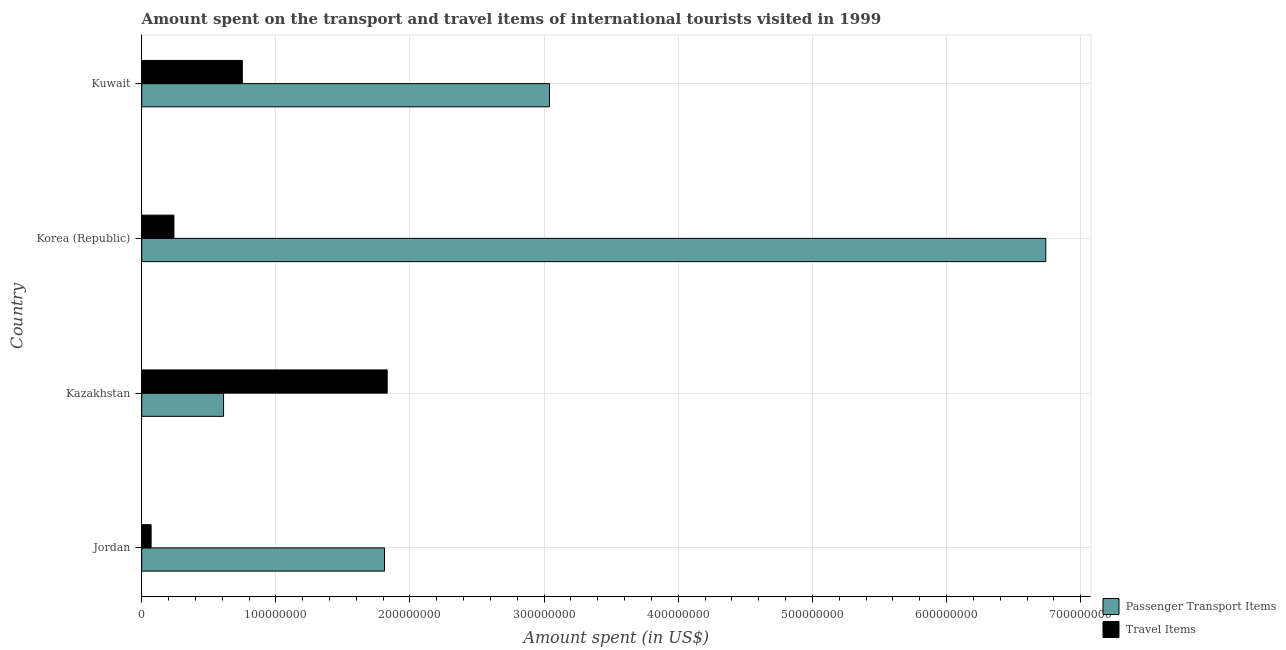Are the number of bars on each tick of the Y-axis equal?
Offer a very short reply. Yes. How many bars are there on the 2nd tick from the bottom?
Offer a terse response. 2. In how many cases, is the number of bars for a given country not equal to the number of legend labels?
Your answer should be very brief. 0. What is the amount spent on passenger transport items in Kazakhstan?
Ensure brevity in your answer.  6.10e+07. Across all countries, what is the maximum amount spent in travel items?
Give a very brief answer. 1.83e+08. Across all countries, what is the minimum amount spent on passenger transport items?
Keep it short and to the point. 6.10e+07. In which country was the amount spent on passenger transport items maximum?
Keep it short and to the point. Korea (Republic). In which country was the amount spent on passenger transport items minimum?
Your answer should be compact. Kazakhstan. What is the total amount spent in travel items in the graph?
Your answer should be compact. 2.89e+08. What is the difference between the amount spent on passenger transport items in Korea (Republic) and that in Kuwait?
Provide a short and direct response. 3.70e+08. What is the difference between the amount spent in travel items in Kuwait and the amount spent on passenger transport items in Jordan?
Ensure brevity in your answer.  -1.06e+08. What is the average amount spent in travel items per country?
Provide a succinct answer. 7.22e+07. What is the difference between the amount spent in travel items and amount spent on passenger transport items in Korea (Republic)?
Offer a very short reply. -6.50e+08. What is the ratio of the amount spent on passenger transport items in Jordan to that in Korea (Republic)?
Provide a short and direct response. 0.27. Is the amount spent on passenger transport items in Jordan less than that in Kazakhstan?
Give a very brief answer. No. What is the difference between the highest and the second highest amount spent on passenger transport items?
Offer a very short reply. 3.70e+08. What is the difference between the highest and the lowest amount spent in travel items?
Your answer should be compact. 1.76e+08. Is the sum of the amount spent in travel items in Jordan and Kuwait greater than the maximum amount spent on passenger transport items across all countries?
Make the answer very short. No. What does the 2nd bar from the top in Kuwait represents?
Give a very brief answer. Passenger Transport Items. What does the 2nd bar from the bottom in Kazakhstan represents?
Ensure brevity in your answer.  Travel Items. How many bars are there?
Provide a short and direct response. 8. How many countries are there in the graph?
Keep it short and to the point. 4. What is the difference between two consecutive major ticks on the X-axis?
Give a very brief answer. 1.00e+08. How are the legend labels stacked?
Provide a succinct answer. Vertical. What is the title of the graph?
Ensure brevity in your answer.  Amount spent on the transport and travel items of international tourists visited in 1999. What is the label or title of the X-axis?
Provide a short and direct response. Amount spent (in US$). What is the Amount spent (in US$) in Passenger Transport Items in Jordan?
Make the answer very short. 1.81e+08. What is the Amount spent (in US$) in Travel Items in Jordan?
Your answer should be very brief. 7.00e+06. What is the Amount spent (in US$) of Passenger Transport Items in Kazakhstan?
Offer a very short reply. 6.10e+07. What is the Amount spent (in US$) in Travel Items in Kazakhstan?
Your answer should be very brief. 1.83e+08. What is the Amount spent (in US$) in Passenger Transport Items in Korea (Republic)?
Offer a terse response. 6.74e+08. What is the Amount spent (in US$) in Travel Items in Korea (Republic)?
Your answer should be very brief. 2.40e+07. What is the Amount spent (in US$) in Passenger Transport Items in Kuwait?
Offer a terse response. 3.04e+08. What is the Amount spent (in US$) in Travel Items in Kuwait?
Provide a succinct answer. 7.50e+07. Across all countries, what is the maximum Amount spent (in US$) in Passenger Transport Items?
Offer a terse response. 6.74e+08. Across all countries, what is the maximum Amount spent (in US$) in Travel Items?
Keep it short and to the point. 1.83e+08. Across all countries, what is the minimum Amount spent (in US$) of Passenger Transport Items?
Give a very brief answer. 6.10e+07. What is the total Amount spent (in US$) in Passenger Transport Items in the graph?
Offer a very short reply. 1.22e+09. What is the total Amount spent (in US$) in Travel Items in the graph?
Provide a succinct answer. 2.89e+08. What is the difference between the Amount spent (in US$) of Passenger Transport Items in Jordan and that in Kazakhstan?
Keep it short and to the point. 1.20e+08. What is the difference between the Amount spent (in US$) in Travel Items in Jordan and that in Kazakhstan?
Give a very brief answer. -1.76e+08. What is the difference between the Amount spent (in US$) of Passenger Transport Items in Jordan and that in Korea (Republic)?
Your answer should be compact. -4.93e+08. What is the difference between the Amount spent (in US$) in Travel Items in Jordan and that in Korea (Republic)?
Offer a very short reply. -1.70e+07. What is the difference between the Amount spent (in US$) of Passenger Transport Items in Jordan and that in Kuwait?
Ensure brevity in your answer.  -1.23e+08. What is the difference between the Amount spent (in US$) of Travel Items in Jordan and that in Kuwait?
Provide a succinct answer. -6.80e+07. What is the difference between the Amount spent (in US$) of Passenger Transport Items in Kazakhstan and that in Korea (Republic)?
Make the answer very short. -6.13e+08. What is the difference between the Amount spent (in US$) of Travel Items in Kazakhstan and that in Korea (Republic)?
Your answer should be very brief. 1.59e+08. What is the difference between the Amount spent (in US$) in Passenger Transport Items in Kazakhstan and that in Kuwait?
Your answer should be compact. -2.43e+08. What is the difference between the Amount spent (in US$) of Travel Items in Kazakhstan and that in Kuwait?
Your answer should be very brief. 1.08e+08. What is the difference between the Amount spent (in US$) in Passenger Transport Items in Korea (Republic) and that in Kuwait?
Keep it short and to the point. 3.70e+08. What is the difference between the Amount spent (in US$) of Travel Items in Korea (Republic) and that in Kuwait?
Your answer should be compact. -5.10e+07. What is the difference between the Amount spent (in US$) of Passenger Transport Items in Jordan and the Amount spent (in US$) of Travel Items in Korea (Republic)?
Provide a succinct answer. 1.57e+08. What is the difference between the Amount spent (in US$) in Passenger Transport Items in Jordan and the Amount spent (in US$) in Travel Items in Kuwait?
Offer a very short reply. 1.06e+08. What is the difference between the Amount spent (in US$) in Passenger Transport Items in Kazakhstan and the Amount spent (in US$) in Travel Items in Korea (Republic)?
Make the answer very short. 3.70e+07. What is the difference between the Amount spent (in US$) of Passenger Transport Items in Kazakhstan and the Amount spent (in US$) of Travel Items in Kuwait?
Ensure brevity in your answer.  -1.40e+07. What is the difference between the Amount spent (in US$) of Passenger Transport Items in Korea (Republic) and the Amount spent (in US$) of Travel Items in Kuwait?
Offer a very short reply. 5.99e+08. What is the average Amount spent (in US$) of Passenger Transport Items per country?
Make the answer very short. 3.05e+08. What is the average Amount spent (in US$) in Travel Items per country?
Make the answer very short. 7.22e+07. What is the difference between the Amount spent (in US$) of Passenger Transport Items and Amount spent (in US$) of Travel Items in Jordan?
Provide a succinct answer. 1.74e+08. What is the difference between the Amount spent (in US$) in Passenger Transport Items and Amount spent (in US$) in Travel Items in Kazakhstan?
Your answer should be compact. -1.22e+08. What is the difference between the Amount spent (in US$) in Passenger Transport Items and Amount spent (in US$) in Travel Items in Korea (Republic)?
Provide a short and direct response. 6.50e+08. What is the difference between the Amount spent (in US$) in Passenger Transport Items and Amount spent (in US$) in Travel Items in Kuwait?
Keep it short and to the point. 2.29e+08. What is the ratio of the Amount spent (in US$) in Passenger Transport Items in Jordan to that in Kazakhstan?
Your response must be concise. 2.97. What is the ratio of the Amount spent (in US$) in Travel Items in Jordan to that in Kazakhstan?
Your answer should be compact. 0.04. What is the ratio of the Amount spent (in US$) in Passenger Transport Items in Jordan to that in Korea (Republic)?
Make the answer very short. 0.27. What is the ratio of the Amount spent (in US$) in Travel Items in Jordan to that in Korea (Republic)?
Make the answer very short. 0.29. What is the ratio of the Amount spent (in US$) of Passenger Transport Items in Jordan to that in Kuwait?
Provide a succinct answer. 0.6. What is the ratio of the Amount spent (in US$) of Travel Items in Jordan to that in Kuwait?
Offer a very short reply. 0.09. What is the ratio of the Amount spent (in US$) in Passenger Transport Items in Kazakhstan to that in Korea (Republic)?
Your response must be concise. 0.09. What is the ratio of the Amount spent (in US$) in Travel Items in Kazakhstan to that in Korea (Republic)?
Offer a very short reply. 7.62. What is the ratio of the Amount spent (in US$) of Passenger Transport Items in Kazakhstan to that in Kuwait?
Ensure brevity in your answer.  0.2. What is the ratio of the Amount spent (in US$) in Travel Items in Kazakhstan to that in Kuwait?
Your response must be concise. 2.44. What is the ratio of the Amount spent (in US$) in Passenger Transport Items in Korea (Republic) to that in Kuwait?
Provide a short and direct response. 2.22. What is the ratio of the Amount spent (in US$) of Travel Items in Korea (Republic) to that in Kuwait?
Your response must be concise. 0.32. What is the difference between the highest and the second highest Amount spent (in US$) of Passenger Transport Items?
Keep it short and to the point. 3.70e+08. What is the difference between the highest and the second highest Amount spent (in US$) in Travel Items?
Provide a succinct answer. 1.08e+08. What is the difference between the highest and the lowest Amount spent (in US$) in Passenger Transport Items?
Your answer should be compact. 6.13e+08. What is the difference between the highest and the lowest Amount spent (in US$) in Travel Items?
Offer a terse response. 1.76e+08. 